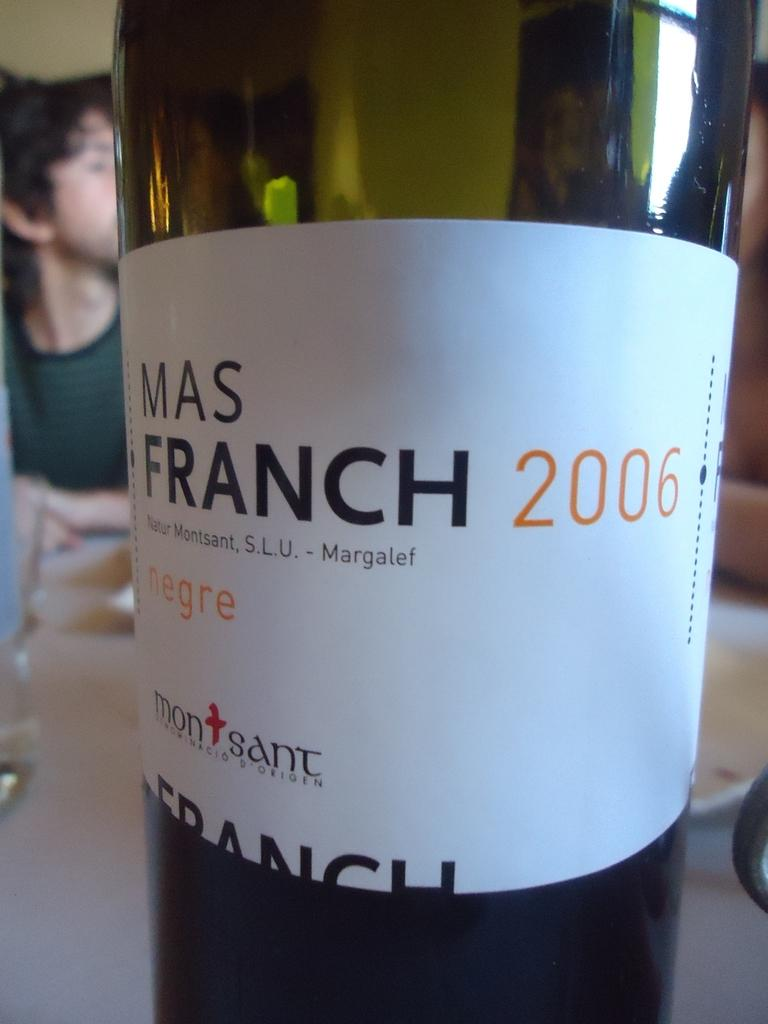<image>
Give a short and clear explanation of the subsequent image. A green transparent bottle of liquid with a white label that reads mas franch 2006 on it. 